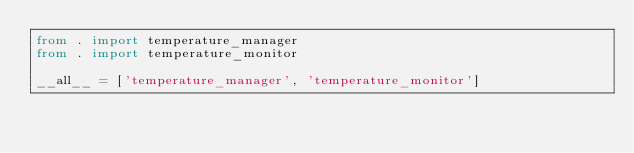Convert code to text. <code><loc_0><loc_0><loc_500><loc_500><_Python_>from . import temperature_manager
from . import temperature_monitor

__all__ = ['temperature_manager', 'temperature_monitor']
</code> 